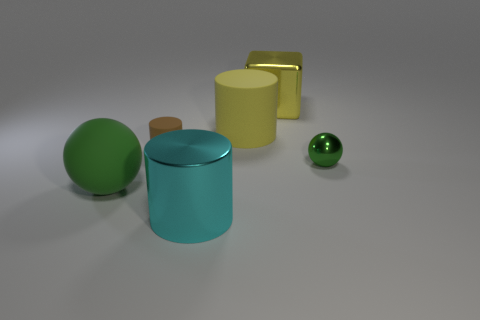Add 3 large things. How many objects exist? 9 Subtract all cubes. How many objects are left? 5 Subtract 0 brown cubes. How many objects are left? 6 Subtract all yellow matte objects. Subtract all large rubber spheres. How many objects are left? 4 Add 5 large green rubber spheres. How many large green rubber spheres are left? 6 Add 4 big brown cylinders. How many big brown cylinders exist? 4 